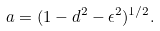Convert formula to latex. <formula><loc_0><loc_0><loc_500><loc_500>a = ( 1 - d ^ { 2 } - \epsilon ^ { 2 } ) ^ { 1 / 2 } .</formula> 